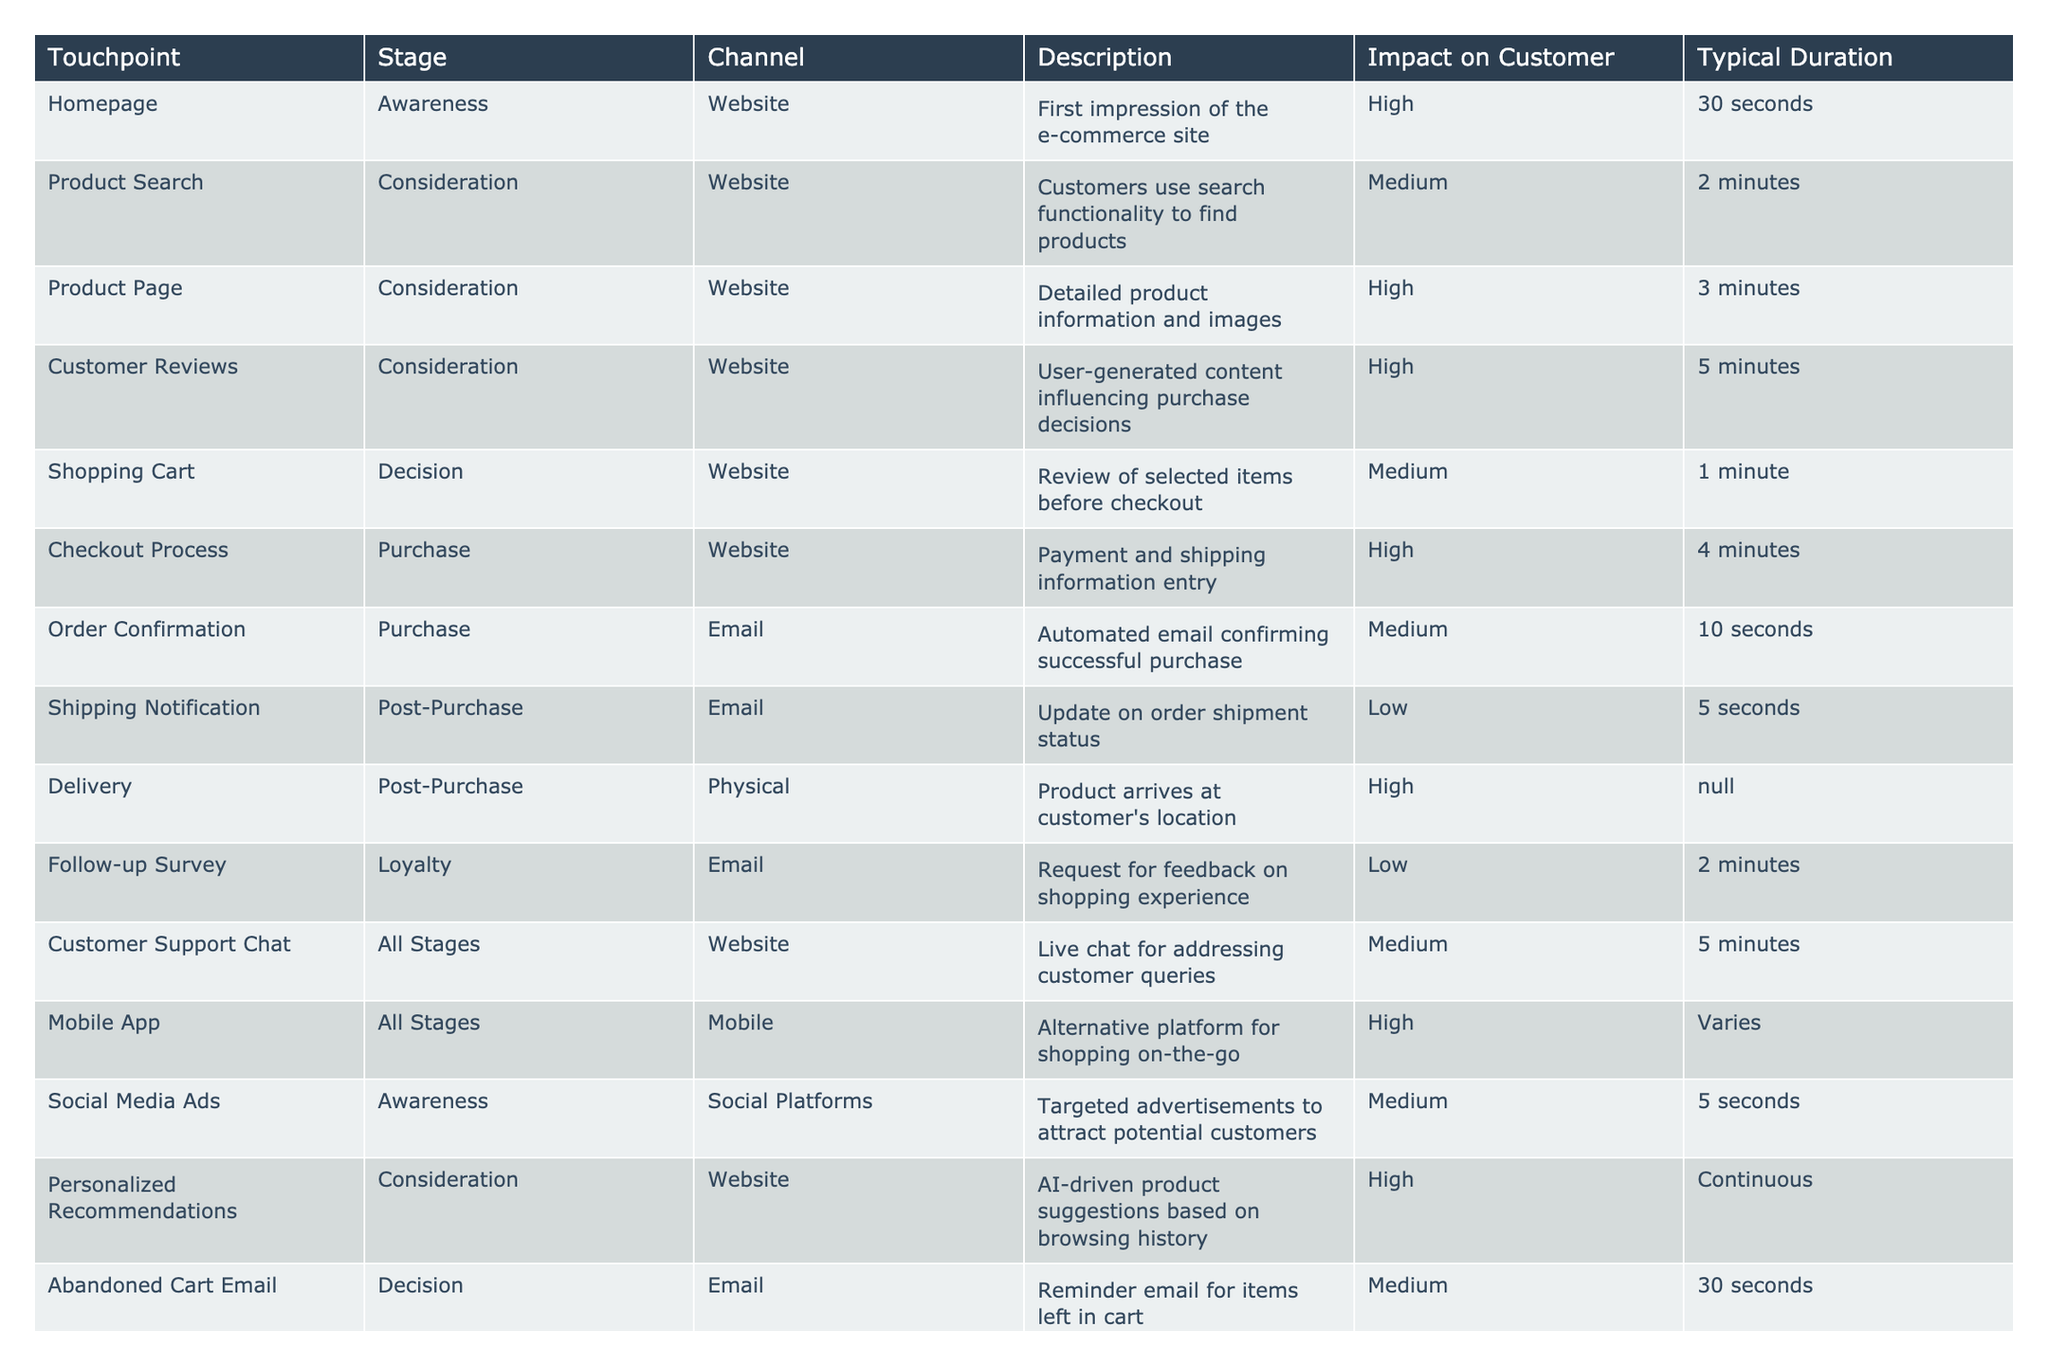What is the impact on customer for the Product Page touchpoint? The Product Page touchpoint has an impact rating of High according to the table. This implies that it significantly affects the customer's perception and decision-making process.
Answer: High How long does the Shopping Cart stage typically last? The table indicates that the typical duration for the Shopping Cart stage is 1 minute. This means that customers spend an average of 1 minute reviewing their selected items before proceeding to checkout.
Answer: 1 minute Which touchpoint has the lowest impact on the customer, and what is that impact? Reviewing the table, the Shipping Notification touchpoint has the lowest impact on customers, classified as Low. This suggests that updates on shipment status are not as influential as other touchpoints in the customer journey.
Answer: Shipping Notification, Low What are the durations for the Awareness stage touchpoints? The Awareness stage consists of the Homepage and Social Media Ads touchpoints. The durations are 30 seconds for the Homepage and 5 seconds for Social Media Ads. This means that the total duration for both is 30 + 5 = 35 seconds.
Answer: 35 seconds Is the Follow-up Survey touchpoint in the Decision stage? No, according to the table, the Follow-up Survey touchpoint is in the Loyalty stage. This indicates that it occurs after the purchase has been made, aiming to gather feedback on the overall shopping experience.
Answer: No What is the difference in impact ratings between the Checkout Process and the Customer Support Chat? The Checkout Process has an impact rating of High, while the Customer Support Chat has a rating of Medium. This difference indicates that the Checkout Process is considered to have a more significant influence on the customer than the Customer Support Chat.
Answer: High, Medium How many touchpoints are classified with a High impact? In the table, the following touchpoints are classified with a High impact: Product Page, Customer Reviews, Checkout Process, Mobile App, and Personalized Recommendations. This makes a total of 5 touchpoints rated as High.
Answer: 5 Which touchpoint serves as a reminder for items left in the cart? The table specifies that the Abandoned Cart Email serves as a reminder email for items left in the cart. This indicates its purpose in encouraging customers to complete their purchases.
Answer: Abandoned Cart Email What is the total duration of the Consideration stage touchpoints? The Consideration stage includes Product Search (2 minutes), Product Page (3 minutes), Customer Reviews (5 minutes), and Personalized Recommendations (Continuous). To calculate the total duration, we sum the fixed durations: 2 + 3 + 5 = 10 minutes. However, Personalized Recommendations has a continuous duration, which means it cannot be counted in the total. Thus, the effective total duration remains 10 minutes.
Answer: 10 minutes 